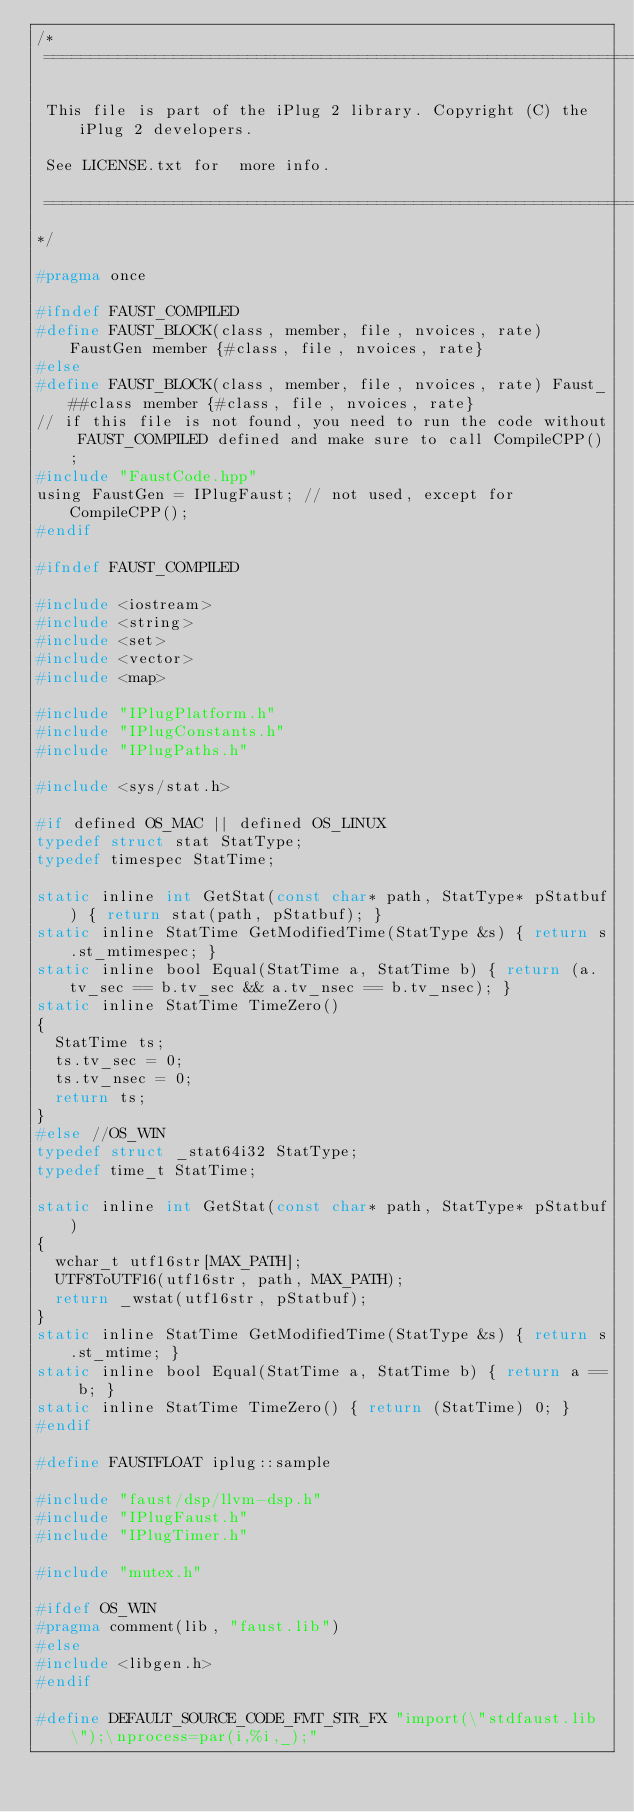Convert code to text. <code><loc_0><loc_0><loc_500><loc_500><_C_>/*
 ==============================================================================
 
 This file is part of the iPlug 2 library. Copyright (C) the iPlug 2 developers. 
 
 See LICENSE.txt for  more info.
 
 ==============================================================================
*/

#pragma once

#ifndef FAUST_COMPILED
#define FAUST_BLOCK(class, member, file, nvoices, rate) FaustGen member {#class, file, nvoices, rate}
#else
#define FAUST_BLOCK(class, member, file, nvoices, rate) Faust_##class member {#class, file, nvoices, rate}
// if this file is not found, you need to run the code without FAUST_COMPILED defined and make sure to call CompileCPP();
#include "FaustCode.hpp"
using FaustGen = IPlugFaust; // not used, except for CompileCPP();
#endif

#ifndef FAUST_COMPILED

#include <iostream>
#include <string>
#include <set>
#include <vector>
#include <map>

#include "IPlugPlatform.h"
#include "IPlugConstants.h"
#include "IPlugPaths.h"

#include <sys/stat.h>

#if defined OS_MAC || defined OS_LINUX
typedef struct stat StatType;
typedef timespec StatTime;

static inline int GetStat(const char* path, StatType* pStatbuf) { return stat(path, pStatbuf); }
static inline StatTime GetModifiedTime(StatType &s) { return s.st_mtimespec; }
static inline bool Equal(StatTime a, StatTime b) { return (a.tv_sec == b.tv_sec && a.tv_nsec == b.tv_nsec); }
static inline StatTime TimeZero()
{
  StatTime ts;
  ts.tv_sec = 0;
  ts.tv_nsec = 0;
  return ts;
}
#else //OS_WIN
typedef struct _stat64i32 StatType;
typedef time_t StatTime;

static inline int GetStat(const char* path, StatType* pStatbuf)
{
  wchar_t utf16str[MAX_PATH];
  UTF8ToUTF16(utf16str, path, MAX_PATH);
  return _wstat(utf16str, pStatbuf);
}
static inline StatTime GetModifiedTime(StatType &s) { return s.st_mtime; }
static inline bool Equal(StatTime a, StatTime b) { return a == b; }
static inline StatTime TimeZero() { return (StatTime) 0; }
#endif

#define FAUSTFLOAT iplug::sample

#include "faust/dsp/llvm-dsp.h"
#include "IPlugFaust.h"
#include "IPlugTimer.h"

#include "mutex.h"

#ifdef OS_WIN
#pragma comment(lib, "faust.lib")
#else
#include <libgen.h>
#endif

#define DEFAULT_SOURCE_CODE_FMT_STR_FX "import(\"stdfaust.lib\");\nprocess=par(i,%i,_);"</code> 